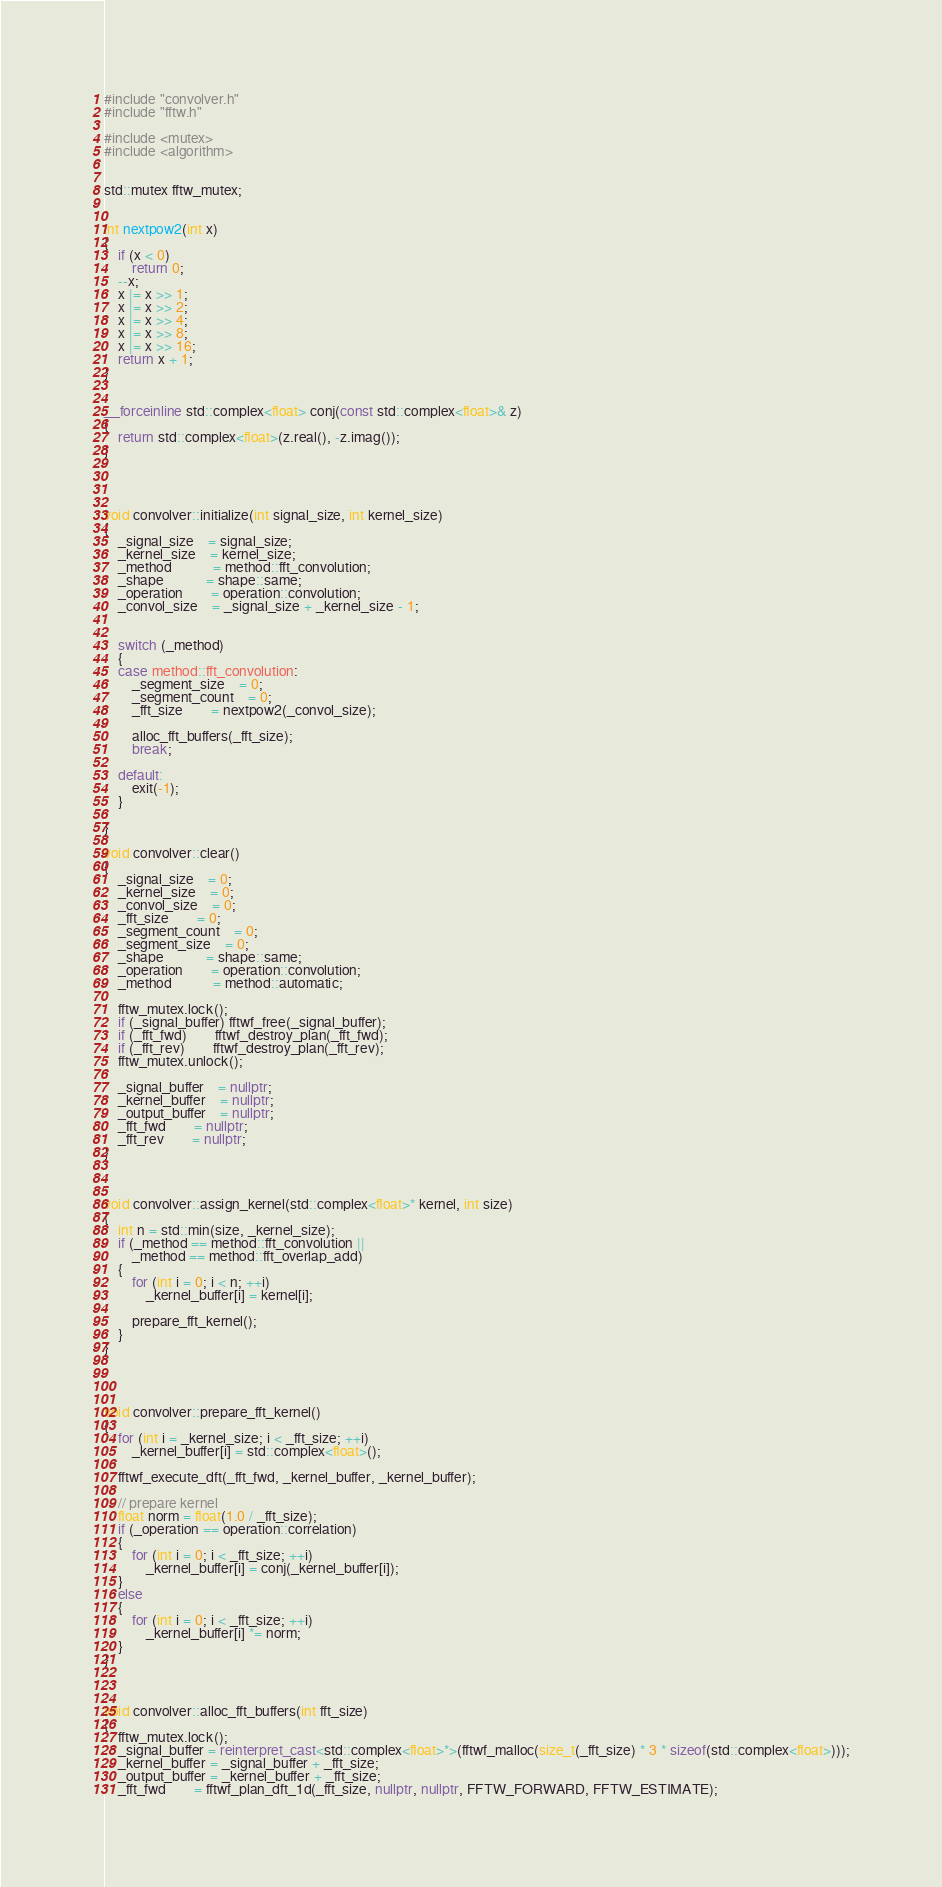Convert code to text. <code><loc_0><loc_0><loc_500><loc_500><_C++_>#include "convolver.h"
#include "fftw.h"

#include <mutex>
#include <algorithm>


std::mutex fftw_mutex;


int nextpow2(int x)
{
	if (x < 0)
		return 0;
	--x;
	x |= x >> 1;
	x |= x >> 2;
	x |= x >> 4;
	x |= x >> 8;
	x |= x >> 16;
	return x + 1;
}


__forceinline std::complex<float> conj(const std::complex<float>& z)
{
	return std::complex<float>(z.real(), -z.imag());
}




void convolver::initialize(int signal_size, int kernel_size)
{
	_signal_size	= signal_size;
	_kernel_size	= kernel_size;
	_method			= method::fft_convolution;
	_shape			= shape::same;
	_operation		= operation::convolution;
	_convol_size	= _signal_size + _kernel_size - 1;


	switch (_method)
	{
	case method::fft_convolution:
		_segment_size	= 0;
		_segment_count	= 0;
		_fft_size		= nextpow2(_convol_size);

		alloc_fft_buffers(_fft_size);
		break;

	default:
		exit(-1);
	}

}

void convolver::clear()
{
	_signal_size	= 0;
	_kernel_size	= 0;
	_convol_size	= 0;
	_fft_size		= 0;
	_segment_count	= 0;
	_segment_size 	= 0;
	_shape			= shape::same;
	_operation		= operation::convolution;
	_method			= method::automatic;

	fftw_mutex.lock();
	if (_signal_buffer) fftwf_free(_signal_buffer);
	if (_fft_fwd)		fftwf_destroy_plan(_fft_fwd);
	if (_fft_rev)		fftwf_destroy_plan(_fft_rev);
	fftw_mutex.unlock();

	_signal_buffer	= nullptr;
	_kernel_buffer	= nullptr;
	_output_buffer	= nullptr;
	_fft_fwd		= nullptr;
	_fft_rev		= nullptr;
}



void convolver::assign_kernel(std::complex<float>* kernel, int size)
{
	int n = std::min(size, _kernel_size);
	if (_method == method::fft_convolution ||
		_method == method::fft_overlap_add)
	{
		for (int i = 0; i < n; ++i)
			_kernel_buffer[i] = kernel[i];

		prepare_fft_kernel();
	}
}




void convolver::prepare_fft_kernel()
{
	for (int i = _kernel_size; i < _fft_size; ++i)
		_kernel_buffer[i] = std::complex<float>();

	fftwf_execute_dft(_fft_fwd, _kernel_buffer, _kernel_buffer);

	// prepare kernel
	float norm = float(1.0 / _fft_size);
	if (_operation == operation::correlation)
	{
		for (int i = 0; i < _fft_size; ++i)
			_kernel_buffer[i] = conj(_kernel_buffer[i]);
	}
	else
	{
		for (int i = 0; i < _fft_size; ++i)
			_kernel_buffer[i] *= norm;
	}
}



void convolver::alloc_fft_buffers(int fft_size)
{
	fftw_mutex.lock();
	_signal_buffer = reinterpret_cast<std::complex<float>*>(fftwf_malloc(size_t(_fft_size) * 3 * sizeof(std::complex<float>)));
	_kernel_buffer = _signal_buffer + _fft_size;
	_output_buffer = _kernel_buffer + _fft_size;
	_fft_fwd		= fftwf_plan_dft_1d(_fft_size, nullptr, nullptr, FFTW_FORWARD, FFTW_ESTIMATE);</code> 